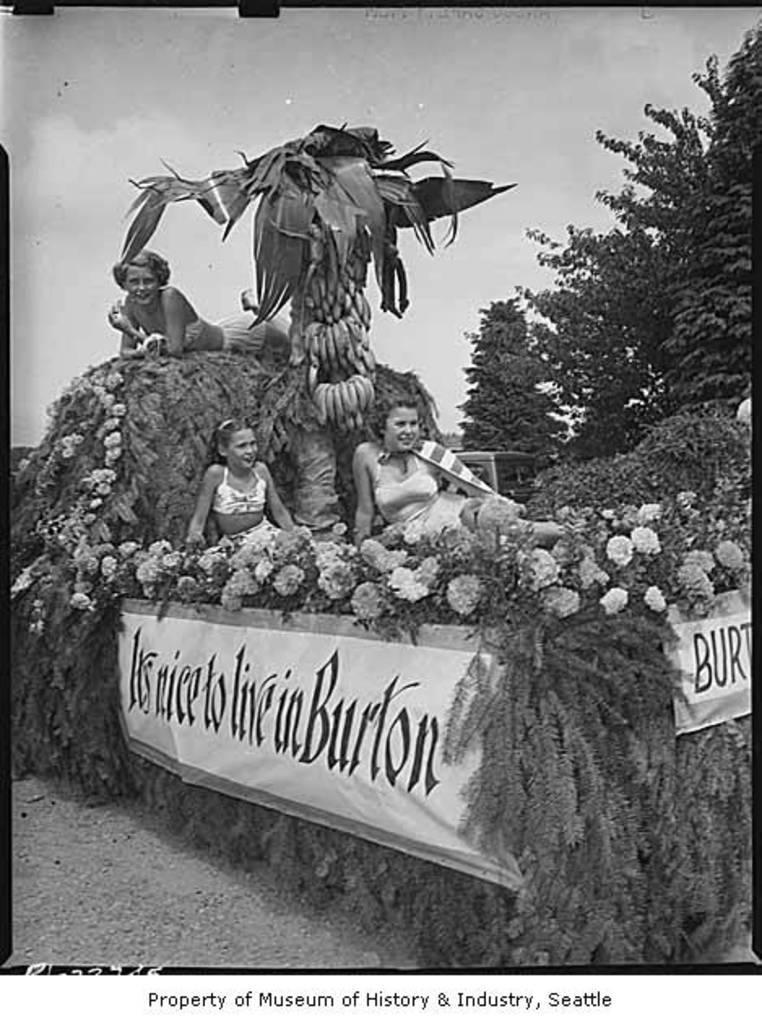Please provide a concise description of this image. In this image I can see number of flowers, few boards, number of bananas, leaves and few people over here. On these words I can see something is written. 